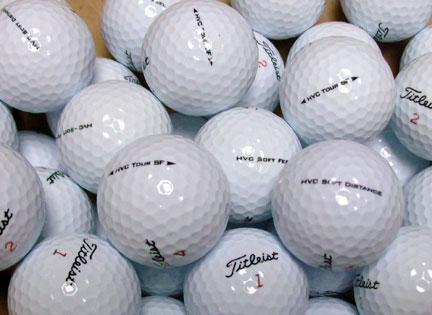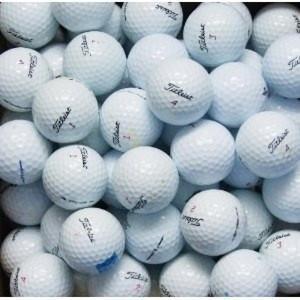The first image is the image on the left, the second image is the image on the right. Assess this claim about the two images: "The balls in the image on the right are not in shadow.". Correct or not? Answer yes or no. Yes. 